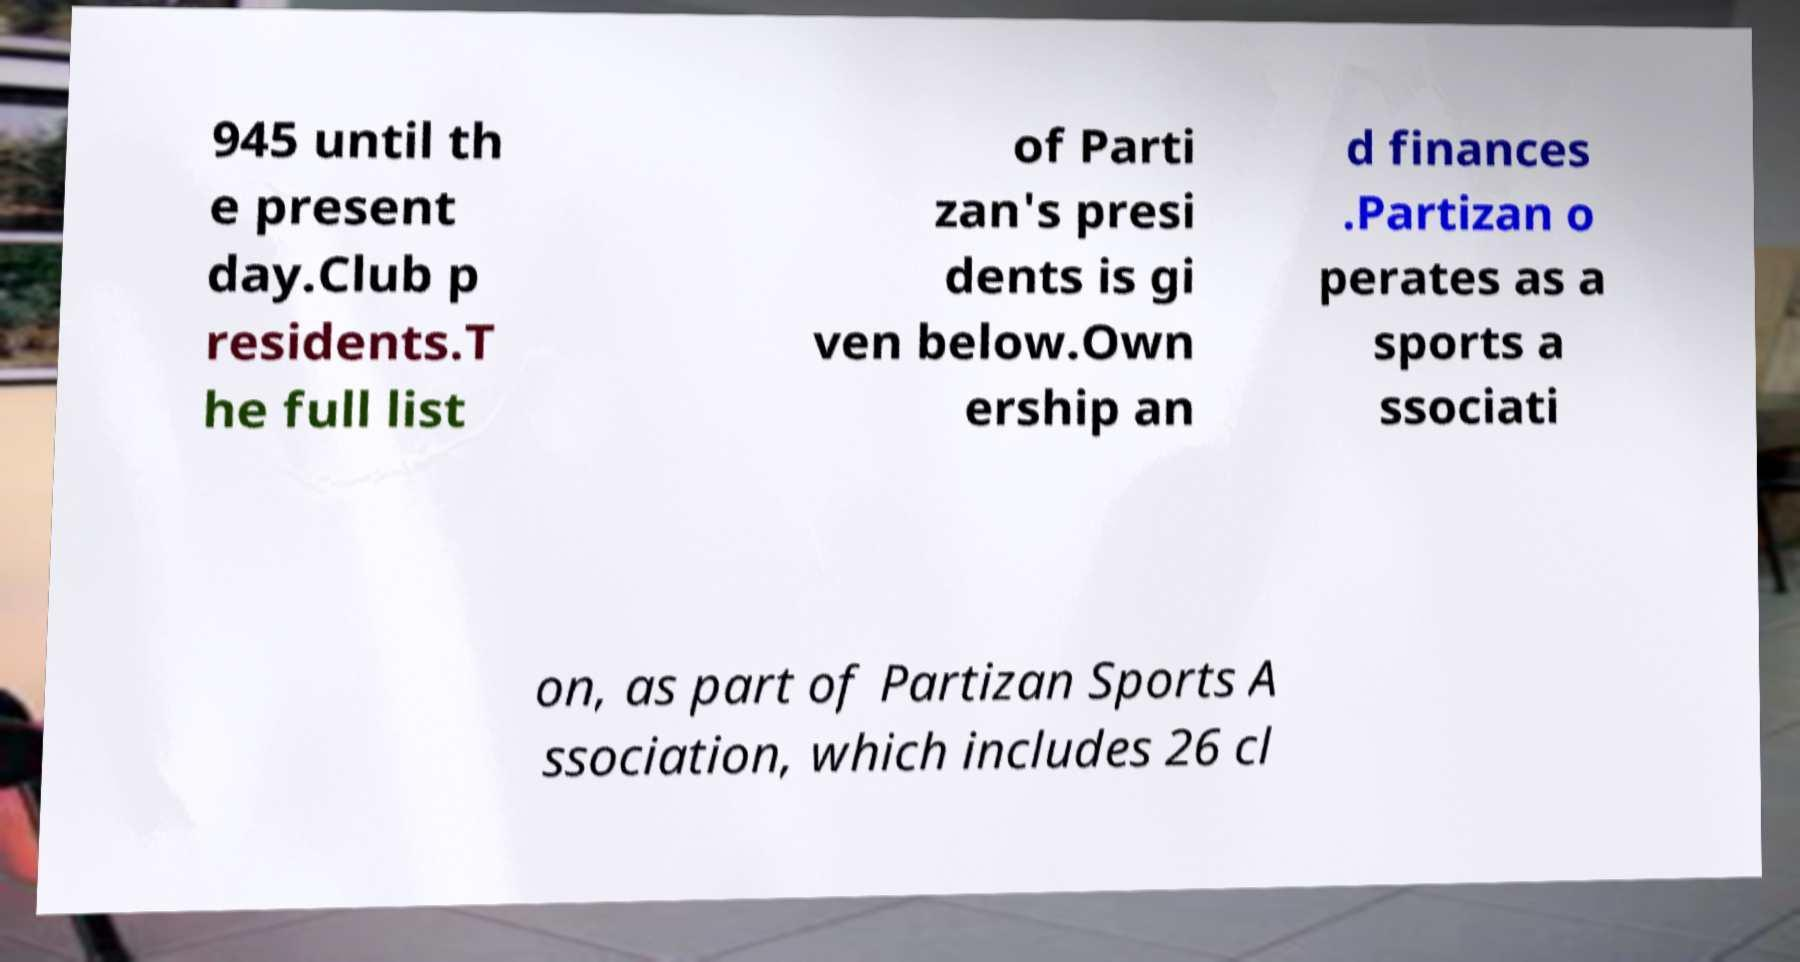Can you accurately transcribe the text from the provided image for me? 945 until th e present day.Club p residents.T he full list of Parti zan's presi dents is gi ven below.Own ership an d finances .Partizan o perates as a sports a ssociati on, as part of Partizan Sports A ssociation, which includes 26 cl 